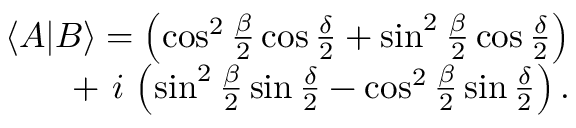<formula> <loc_0><loc_0><loc_500><loc_500>\begin{array} { r } { \langle A | B \rangle = \left ( \cos ^ { 2 } { \frac { \beta } { 2 } } \cos { \frac { \delta } { 2 } } + \sin ^ { 2 } { \frac { \beta } { 2 } } \cos { \frac { \delta } { 2 } } \right ) } \\ { + \, i \, \left ( \sin ^ { 2 } { \frac { \beta } { 2 } } \sin { \frac { \delta } { 2 } } - \cos ^ { 2 } { \frac { \beta } { 2 } } \sin { \frac { \delta } { 2 } } \right ) . } \end{array}</formula> 